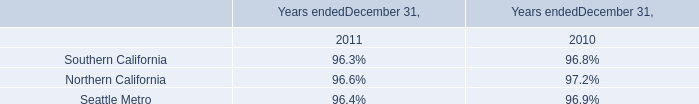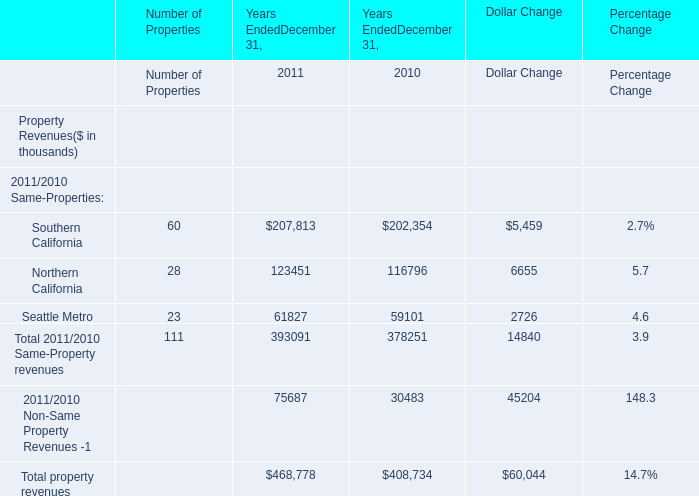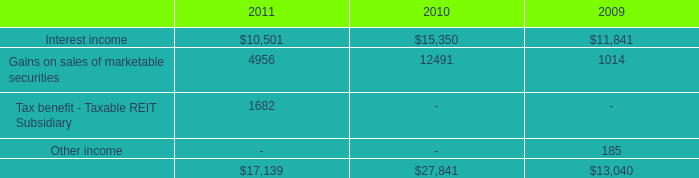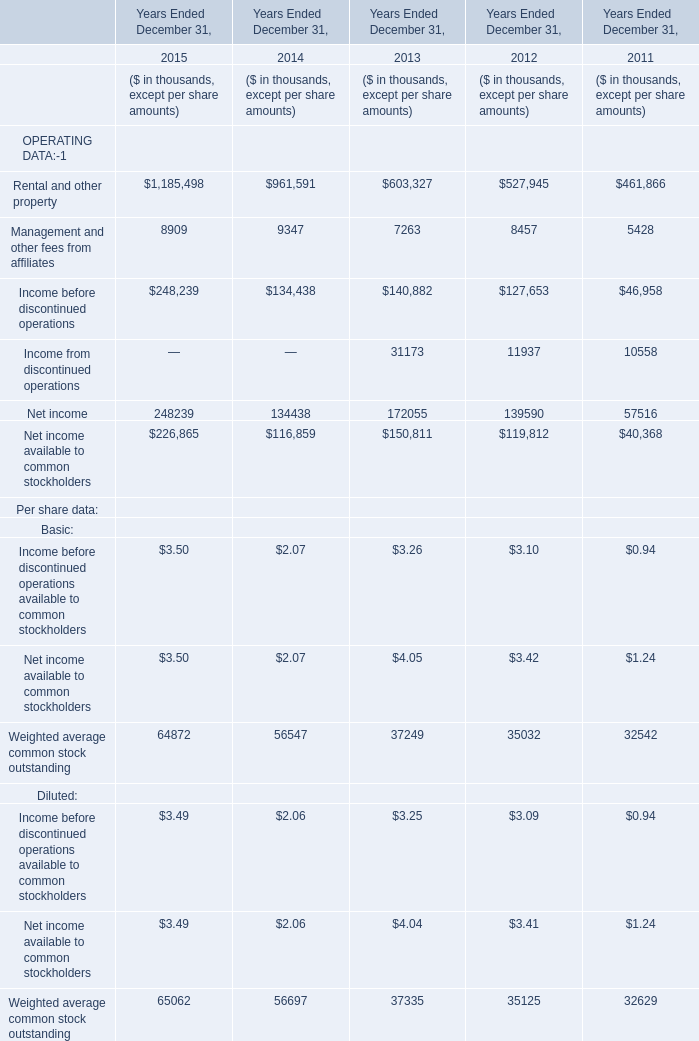What is the total amount of Northern California of Years EndedDecember 31, 2010, and Gains on sales of marketable securities of 2011 ? 
Computations: (116796.0 + 4956.0)
Answer: 121752.0. 